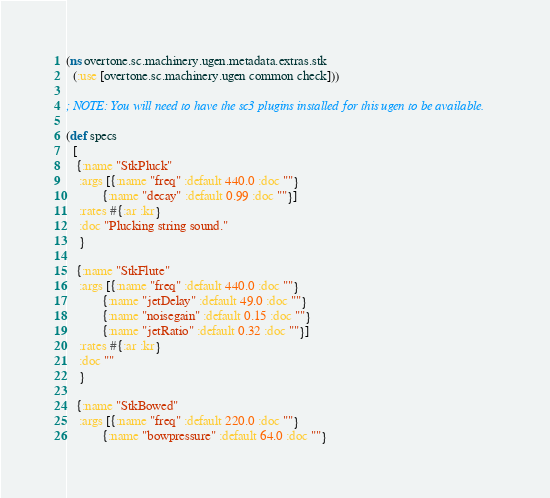Convert code to text. <code><loc_0><loc_0><loc_500><loc_500><_Clojure_>(ns overtone.sc.machinery.ugen.metadata.extras.stk
  (:use [overtone.sc.machinery.ugen common check]))

; NOTE: You will need to have the sc3 plugins installed for this ugen to be available.

(def specs
  [
   {:name "StkPluck"
    :args [{:name "freq" :default 440.0 :doc ""}
           {:name "decay" :default 0.99 :doc ""}]
    :rates #{:ar :kr}
    :doc "Plucking string sound."
    }

   {:name "StkFlute"
    :args [{:name "freq" :default 440.0 :doc ""}
           {:name "jetDelay" :default 49.0 :doc ""}
           {:name "noisegain" :default 0.15 :doc ""}
           {:name "jetRatio" :default 0.32 :doc ""}]
    :rates #{:ar :kr}
    :doc ""
    }

   {:name "StkBowed"
    :args [{:name "freq" :default 220.0 :doc ""}
           {:name "bowpressure" :default 64.0 :doc ""}</code> 